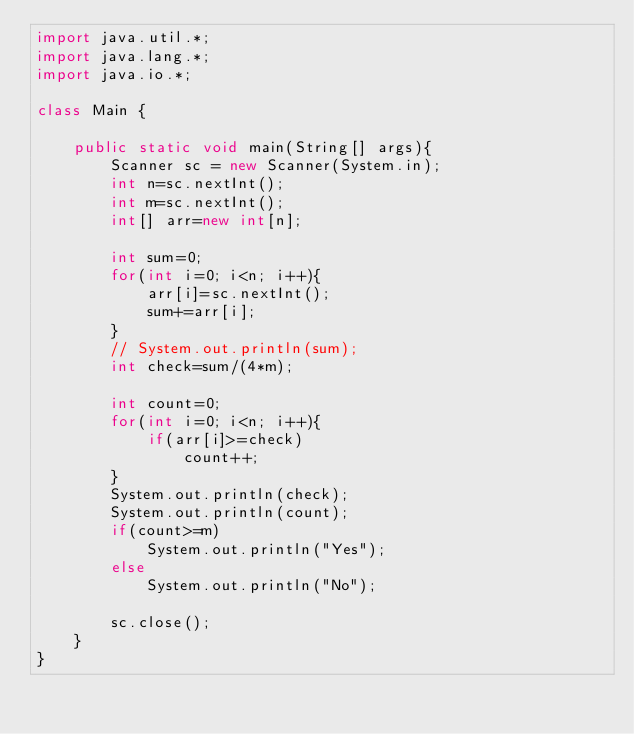<code> <loc_0><loc_0><loc_500><loc_500><_Java_>import java.util.*;
import java.lang.*;
import java.io.*;

class Main {

	public static void main(String[] args){
		Scanner sc = new Scanner(System.in);
		int n=sc.nextInt();
        int m=sc.nextInt();
        int[] arr=new int[n];
        
        int sum=0;
        for(int i=0; i<n; i++){
        	arr[i]=sc.nextInt();
        	sum+=arr[i];
        }
        // System.out.println(sum);
        int check=sum/(4*m);

        int count=0;
        for(int i=0; i<n; i++){
        	if(arr[i]>=check)
        		count++;	
        }
        System.out.println(check);
        System.out.println(count);
        if(count>=m)
        	System.out.println("Yes");
        else
        	System.out.println("No");

		sc.close();
	}
}</code> 